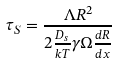<formula> <loc_0><loc_0><loc_500><loc_500>\tau _ { S } = \frac { \Lambda R ^ { 2 } } { 2 \frac { D _ { s } } { k T } \gamma \Omega \frac { d R } { d x } }</formula> 